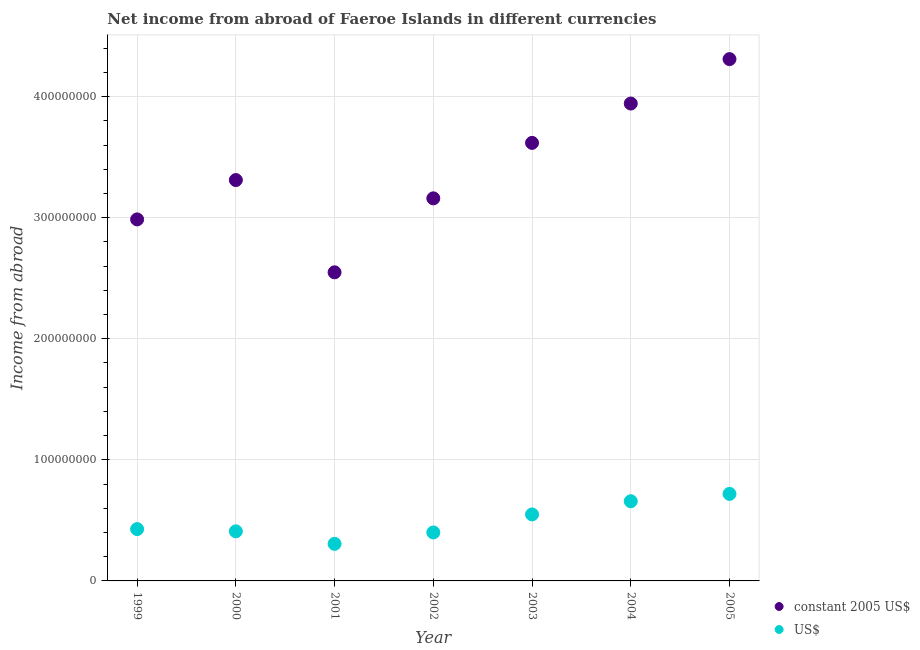What is the income from abroad in constant 2005 us$ in 2001?
Your response must be concise. 2.55e+08. Across all years, what is the maximum income from abroad in constant 2005 us$?
Offer a terse response. 4.31e+08. Across all years, what is the minimum income from abroad in constant 2005 us$?
Keep it short and to the point. 2.55e+08. What is the total income from abroad in constant 2005 us$ in the graph?
Keep it short and to the point. 2.39e+09. What is the difference between the income from abroad in us$ in 2002 and that in 2004?
Provide a short and direct response. -2.58e+07. What is the difference between the income from abroad in constant 2005 us$ in 2001 and the income from abroad in us$ in 2004?
Provide a succinct answer. 1.89e+08. What is the average income from abroad in constant 2005 us$ per year?
Provide a succinct answer. 3.41e+08. In the year 2004, what is the difference between the income from abroad in constant 2005 us$ and income from abroad in us$?
Make the answer very short. 3.28e+08. What is the ratio of the income from abroad in us$ in 2002 to that in 2003?
Provide a short and direct response. 0.73. What is the difference between the highest and the second highest income from abroad in us$?
Your answer should be compact. 6.06e+06. What is the difference between the highest and the lowest income from abroad in us$?
Keep it short and to the point. 4.12e+07. In how many years, is the income from abroad in us$ greater than the average income from abroad in us$ taken over all years?
Provide a short and direct response. 3. Is the income from abroad in us$ strictly greater than the income from abroad in constant 2005 us$ over the years?
Keep it short and to the point. No. Is the income from abroad in us$ strictly less than the income from abroad in constant 2005 us$ over the years?
Make the answer very short. Yes. Are the values on the major ticks of Y-axis written in scientific E-notation?
Offer a terse response. No. Does the graph contain any zero values?
Give a very brief answer. No. Does the graph contain grids?
Your response must be concise. Yes. What is the title of the graph?
Offer a very short reply. Net income from abroad of Faeroe Islands in different currencies. What is the label or title of the X-axis?
Offer a terse response. Year. What is the label or title of the Y-axis?
Offer a terse response. Income from abroad. What is the Income from abroad in constant 2005 US$ in 1999?
Provide a short and direct response. 2.99e+08. What is the Income from abroad of US$ in 1999?
Give a very brief answer. 4.28e+07. What is the Income from abroad of constant 2005 US$ in 2000?
Provide a short and direct response. 3.31e+08. What is the Income from abroad in US$ in 2000?
Your answer should be very brief. 4.10e+07. What is the Income from abroad in constant 2005 US$ in 2001?
Make the answer very short. 2.55e+08. What is the Income from abroad of US$ in 2001?
Your answer should be very brief. 3.06e+07. What is the Income from abroad of constant 2005 US$ in 2002?
Your answer should be very brief. 3.16e+08. What is the Income from abroad of US$ in 2002?
Your response must be concise. 4.00e+07. What is the Income from abroad in constant 2005 US$ in 2003?
Make the answer very short. 3.62e+08. What is the Income from abroad of US$ in 2003?
Provide a short and direct response. 5.49e+07. What is the Income from abroad of constant 2005 US$ in 2004?
Your answer should be compact. 3.94e+08. What is the Income from abroad in US$ in 2004?
Your answer should be compact. 6.58e+07. What is the Income from abroad of constant 2005 US$ in 2005?
Provide a short and direct response. 4.31e+08. What is the Income from abroad of US$ in 2005?
Make the answer very short. 7.19e+07. Across all years, what is the maximum Income from abroad in constant 2005 US$?
Make the answer very short. 4.31e+08. Across all years, what is the maximum Income from abroad of US$?
Ensure brevity in your answer.  7.19e+07. Across all years, what is the minimum Income from abroad of constant 2005 US$?
Ensure brevity in your answer.  2.55e+08. Across all years, what is the minimum Income from abroad in US$?
Give a very brief answer. 3.06e+07. What is the total Income from abroad of constant 2005 US$ in the graph?
Provide a short and direct response. 2.39e+09. What is the total Income from abroad in US$ in the graph?
Your answer should be very brief. 3.47e+08. What is the difference between the Income from abroad of constant 2005 US$ in 1999 and that in 2000?
Your answer should be very brief. -3.25e+07. What is the difference between the Income from abroad in US$ in 1999 and that in 2000?
Offer a very short reply. 1.84e+06. What is the difference between the Income from abroad in constant 2005 US$ in 1999 and that in 2001?
Ensure brevity in your answer.  4.37e+07. What is the difference between the Income from abroad in US$ in 1999 and that in 2001?
Provide a succinct answer. 1.22e+07. What is the difference between the Income from abroad of constant 2005 US$ in 1999 and that in 2002?
Provide a succinct answer. -1.74e+07. What is the difference between the Income from abroad of US$ in 1999 and that in 2002?
Your answer should be very brief. 2.78e+06. What is the difference between the Income from abroad of constant 2005 US$ in 1999 and that in 2003?
Your answer should be very brief. -6.32e+07. What is the difference between the Income from abroad of US$ in 1999 and that in 2003?
Provide a succinct answer. -1.21e+07. What is the difference between the Income from abroad of constant 2005 US$ in 1999 and that in 2004?
Make the answer very short. -9.57e+07. What is the difference between the Income from abroad in US$ in 1999 and that in 2004?
Your answer should be very brief. -2.30e+07. What is the difference between the Income from abroad in constant 2005 US$ in 1999 and that in 2005?
Offer a terse response. -1.32e+08. What is the difference between the Income from abroad in US$ in 1999 and that in 2005?
Your response must be concise. -2.91e+07. What is the difference between the Income from abroad in constant 2005 US$ in 2000 and that in 2001?
Offer a very short reply. 7.62e+07. What is the difference between the Income from abroad of US$ in 2000 and that in 2001?
Make the answer very short. 1.03e+07. What is the difference between the Income from abroad in constant 2005 US$ in 2000 and that in 2002?
Offer a terse response. 1.51e+07. What is the difference between the Income from abroad in US$ in 2000 and that in 2002?
Provide a short and direct response. 9.35e+05. What is the difference between the Income from abroad in constant 2005 US$ in 2000 and that in 2003?
Your answer should be compact. -3.07e+07. What is the difference between the Income from abroad of US$ in 2000 and that in 2003?
Provide a succinct answer. -1.40e+07. What is the difference between the Income from abroad in constant 2005 US$ in 2000 and that in 2004?
Your answer should be very brief. -6.32e+07. What is the difference between the Income from abroad of US$ in 2000 and that in 2004?
Provide a succinct answer. -2.49e+07. What is the difference between the Income from abroad in constant 2005 US$ in 2000 and that in 2005?
Your answer should be compact. -9.99e+07. What is the difference between the Income from abroad in US$ in 2000 and that in 2005?
Provide a succinct answer. -3.09e+07. What is the difference between the Income from abroad in constant 2005 US$ in 2001 and that in 2002?
Make the answer very short. -6.11e+07. What is the difference between the Income from abroad in US$ in 2001 and that in 2002?
Your answer should be compact. -9.40e+06. What is the difference between the Income from abroad of constant 2005 US$ in 2001 and that in 2003?
Keep it short and to the point. -1.07e+08. What is the difference between the Income from abroad of US$ in 2001 and that in 2003?
Your answer should be very brief. -2.43e+07. What is the difference between the Income from abroad of constant 2005 US$ in 2001 and that in 2004?
Provide a short and direct response. -1.39e+08. What is the difference between the Income from abroad in US$ in 2001 and that in 2004?
Ensure brevity in your answer.  -3.52e+07. What is the difference between the Income from abroad in constant 2005 US$ in 2001 and that in 2005?
Your response must be concise. -1.76e+08. What is the difference between the Income from abroad of US$ in 2001 and that in 2005?
Ensure brevity in your answer.  -4.12e+07. What is the difference between the Income from abroad of constant 2005 US$ in 2002 and that in 2003?
Offer a very short reply. -4.58e+07. What is the difference between the Income from abroad in US$ in 2002 and that in 2003?
Your response must be concise. -1.49e+07. What is the difference between the Income from abroad of constant 2005 US$ in 2002 and that in 2004?
Keep it short and to the point. -7.83e+07. What is the difference between the Income from abroad in US$ in 2002 and that in 2004?
Offer a very short reply. -2.58e+07. What is the difference between the Income from abroad in constant 2005 US$ in 2002 and that in 2005?
Give a very brief answer. -1.15e+08. What is the difference between the Income from abroad of US$ in 2002 and that in 2005?
Your response must be concise. -3.18e+07. What is the difference between the Income from abroad of constant 2005 US$ in 2003 and that in 2004?
Your answer should be very brief. -3.25e+07. What is the difference between the Income from abroad of US$ in 2003 and that in 2004?
Ensure brevity in your answer.  -1.09e+07. What is the difference between the Income from abroad in constant 2005 US$ in 2003 and that in 2005?
Make the answer very short. -6.92e+07. What is the difference between the Income from abroad in US$ in 2003 and that in 2005?
Offer a very short reply. -1.69e+07. What is the difference between the Income from abroad of constant 2005 US$ in 2004 and that in 2005?
Offer a terse response. -3.67e+07. What is the difference between the Income from abroad in US$ in 2004 and that in 2005?
Provide a succinct answer. -6.06e+06. What is the difference between the Income from abroad of constant 2005 US$ in 1999 and the Income from abroad of US$ in 2000?
Ensure brevity in your answer.  2.58e+08. What is the difference between the Income from abroad of constant 2005 US$ in 1999 and the Income from abroad of US$ in 2001?
Provide a succinct answer. 2.68e+08. What is the difference between the Income from abroad of constant 2005 US$ in 1999 and the Income from abroad of US$ in 2002?
Offer a terse response. 2.59e+08. What is the difference between the Income from abroad in constant 2005 US$ in 1999 and the Income from abroad in US$ in 2003?
Your answer should be very brief. 2.44e+08. What is the difference between the Income from abroad of constant 2005 US$ in 1999 and the Income from abroad of US$ in 2004?
Make the answer very short. 2.33e+08. What is the difference between the Income from abroad of constant 2005 US$ in 1999 and the Income from abroad of US$ in 2005?
Offer a very short reply. 2.27e+08. What is the difference between the Income from abroad of constant 2005 US$ in 2000 and the Income from abroad of US$ in 2001?
Make the answer very short. 3.00e+08. What is the difference between the Income from abroad in constant 2005 US$ in 2000 and the Income from abroad in US$ in 2002?
Offer a terse response. 2.91e+08. What is the difference between the Income from abroad in constant 2005 US$ in 2000 and the Income from abroad in US$ in 2003?
Offer a terse response. 2.76e+08. What is the difference between the Income from abroad in constant 2005 US$ in 2000 and the Income from abroad in US$ in 2004?
Provide a succinct answer. 2.65e+08. What is the difference between the Income from abroad in constant 2005 US$ in 2000 and the Income from abroad in US$ in 2005?
Provide a succinct answer. 2.59e+08. What is the difference between the Income from abroad in constant 2005 US$ in 2001 and the Income from abroad in US$ in 2002?
Keep it short and to the point. 2.15e+08. What is the difference between the Income from abroad in constant 2005 US$ in 2001 and the Income from abroad in US$ in 2003?
Your response must be concise. 2.00e+08. What is the difference between the Income from abroad in constant 2005 US$ in 2001 and the Income from abroad in US$ in 2004?
Offer a very short reply. 1.89e+08. What is the difference between the Income from abroad in constant 2005 US$ in 2001 and the Income from abroad in US$ in 2005?
Ensure brevity in your answer.  1.83e+08. What is the difference between the Income from abroad in constant 2005 US$ in 2002 and the Income from abroad in US$ in 2003?
Provide a short and direct response. 2.61e+08. What is the difference between the Income from abroad in constant 2005 US$ in 2002 and the Income from abroad in US$ in 2004?
Ensure brevity in your answer.  2.50e+08. What is the difference between the Income from abroad in constant 2005 US$ in 2002 and the Income from abroad in US$ in 2005?
Ensure brevity in your answer.  2.44e+08. What is the difference between the Income from abroad in constant 2005 US$ in 2003 and the Income from abroad in US$ in 2004?
Your answer should be compact. 2.96e+08. What is the difference between the Income from abroad of constant 2005 US$ in 2003 and the Income from abroad of US$ in 2005?
Provide a succinct answer. 2.90e+08. What is the difference between the Income from abroad of constant 2005 US$ in 2004 and the Income from abroad of US$ in 2005?
Give a very brief answer. 3.22e+08. What is the average Income from abroad in constant 2005 US$ per year?
Give a very brief answer. 3.41e+08. What is the average Income from abroad of US$ per year?
Provide a short and direct response. 4.96e+07. In the year 1999, what is the difference between the Income from abroad in constant 2005 US$ and Income from abroad in US$?
Provide a short and direct response. 2.56e+08. In the year 2000, what is the difference between the Income from abroad in constant 2005 US$ and Income from abroad in US$?
Your answer should be compact. 2.90e+08. In the year 2001, what is the difference between the Income from abroad in constant 2005 US$ and Income from abroad in US$?
Your response must be concise. 2.24e+08. In the year 2002, what is the difference between the Income from abroad of constant 2005 US$ and Income from abroad of US$?
Offer a terse response. 2.76e+08. In the year 2003, what is the difference between the Income from abroad in constant 2005 US$ and Income from abroad in US$?
Provide a succinct answer. 3.07e+08. In the year 2004, what is the difference between the Income from abroad in constant 2005 US$ and Income from abroad in US$?
Ensure brevity in your answer.  3.28e+08. In the year 2005, what is the difference between the Income from abroad in constant 2005 US$ and Income from abroad in US$?
Your answer should be very brief. 3.59e+08. What is the ratio of the Income from abroad in constant 2005 US$ in 1999 to that in 2000?
Your answer should be compact. 0.9. What is the ratio of the Income from abroad in US$ in 1999 to that in 2000?
Keep it short and to the point. 1.04. What is the ratio of the Income from abroad of constant 2005 US$ in 1999 to that in 2001?
Provide a short and direct response. 1.17. What is the ratio of the Income from abroad of US$ in 1999 to that in 2001?
Your response must be concise. 1.4. What is the ratio of the Income from abroad of constant 2005 US$ in 1999 to that in 2002?
Ensure brevity in your answer.  0.94. What is the ratio of the Income from abroad in US$ in 1999 to that in 2002?
Provide a short and direct response. 1.07. What is the ratio of the Income from abroad in constant 2005 US$ in 1999 to that in 2003?
Make the answer very short. 0.83. What is the ratio of the Income from abroad of US$ in 1999 to that in 2003?
Your answer should be very brief. 0.78. What is the ratio of the Income from abroad in constant 2005 US$ in 1999 to that in 2004?
Give a very brief answer. 0.76. What is the ratio of the Income from abroad of US$ in 1999 to that in 2004?
Give a very brief answer. 0.65. What is the ratio of the Income from abroad in constant 2005 US$ in 1999 to that in 2005?
Offer a terse response. 0.69. What is the ratio of the Income from abroad of US$ in 1999 to that in 2005?
Offer a terse response. 0.6. What is the ratio of the Income from abroad in constant 2005 US$ in 2000 to that in 2001?
Offer a very short reply. 1.3. What is the ratio of the Income from abroad of US$ in 2000 to that in 2001?
Provide a short and direct response. 1.34. What is the ratio of the Income from abroad of constant 2005 US$ in 2000 to that in 2002?
Your answer should be very brief. 1.05. What is the ratio of the Income from abroad of US$ in 2000 to that in 2002?
Your response must be concise. 1.02. What is the ratio of the Income from abroad of constant 2005 US$ in 2000 to that in 2003?
Provide a succinct answer. 0.92. What is the ratio of the Income from abroad of US$ in 2000 to that in 2003?
Make the answer very short. 0.75. What is the ratio of the Income from abroad in constant 2005 US$ in 2000 to that in 2004?
Make the answer very short. 0.84. What is the ratio of the Income from abroad of US$ in 2000 to that in 2004?
Make the answer very short. 0.62. What is the ratio of the Income from abroad in constant 2005 US$ in 2000 to that in 2005?
Your answer should be compact. 0.77. What is the ratio of the Income from abroad of US$ in 2000 to that in 2005?
Ensure brevity in your answer.  0.57. What is the ratio of the Income from abroad in constant 2005 US$ in 2001 to that in 2002?
Your response must be concise. 0.81. What is the ratio of the Income from abroad of US$ in 2001 to that in 2002?
Ensure brevity in your answer.  0.77. What is the ratio of the Income from abroad of constant 2005 US$ in 2001 to that in 2003?
Ensure brevity in your answer.  0.7. What is the ratio of the Income from abroad of US$ in 2001 to that in 2003?
Provide a succinct answer. 0.56. What is the ratio of the Income from abroad in constant 2005 US$ in 2001 to that in 2004?
Keep it short and to the point. 0.65. What is the ratio of the Income from abroad of US$ in 2001 to that in 2004?
Your answer should be very brief. 0.47. What is the ratio of the Income from abroad in constant 2005 US$ in 2001 to that in 2005?
Your response must be concise. 0.59. What is the ratio of the Income from abroad of US$ in 2001 to that in 2005?
Give a very brief answer. 0.43. What is the ratio of the Income from abroad in constant 2005 US$ in 2002 to that in 2003?
Make the answer very short. 0.87. What is the ratio of the Income from abroad in US$ in 2002 to that in 2003?
Ensure brevity in your answer.  0.73. What is the ratio of the Income from abroad in constant 2005 US$ in 2002 to that in 2004?
Your response must be concise. 0.8. What is the ratio of the Income from abroad in US$ in 2002 to that in 2004?
Keep it short and to the point. 0.61. What is the ratio of the Income from abroad of constant 2005 US$ in 2002 to that in 2005?
Your response must be concise. 0.73. What is the ratio of the Income from abroad in US$ in 2002 to that in 2005?
Your response must be concise. 0.56. What is the ratio of the Income from abroad in constant 2005 US$ in 2003 to that in 2004?
Your response must be concise. 0.92. What is the ratio of the Income from abroad in US$ in 2003 to that in 2004?
Offer a terse response. 0.83. What is the ratio of the Income from abroad of constant 2005 US$ in 2003 to that in 2005?
Your response must be concise. 0.84. What is the ratio of the Income from abroad of US$ in 2003 to that in 2005?
Your answer should be compact. 0.76. What is the ratio of the Income from abroad of constant 2005 US$ in 2004 to that in 2005?
Your answer should be compact. 0.91. What is the ratio of the Income from abroad of US$ in 2004 to that in 2005?
Your answer should be very brief. 0.92. What is the difference between the highest and the second highest Income from abroad in constant 2005 US$?
Your response must be concise. 3.67e+07. What is the difference between the highest and the second highest Income from abroad of US$?
Your answer should be very brief. 6.06e+06. What is the difference between the highest and the lowest Income from abroad of constant 2005 US$?
Keep it short and to the point. 1.76e+08. What is the difference between the highest and the lowest Income from abroad of US$?
Keep it short and to the point. 4.12e+07. 